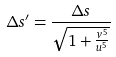Convert formula to latex. <formula><loc_0><loc_0><loc_500><loc_500>\Delta s ^ { \prime } = \frac { \Delta s } { \sqrt { 1 + \frac { v ^ { 5 } } { u ^ { 5 } } } }</formula> 